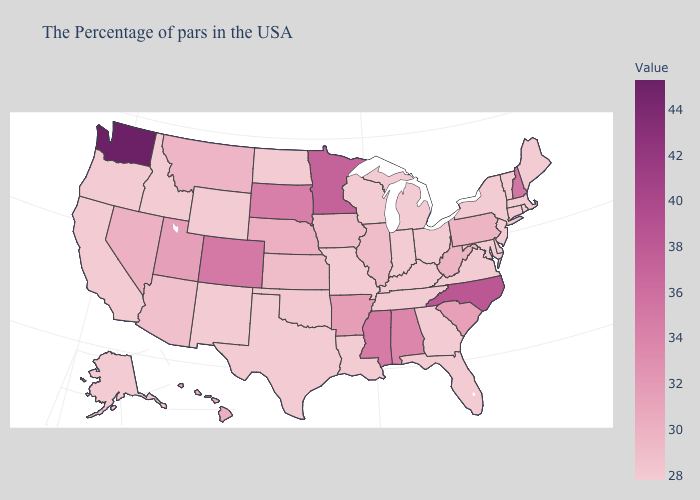Which states have the highest value in the USA?
Quick response, please. Washington. Which states have the lowest value in the West?
Be succinct. Wyoming, New Mexico, Idaho, California, Oregon, Alaska. Does New Hampshire have the highest value in the Northeast?
Answer briefly. Yes. 